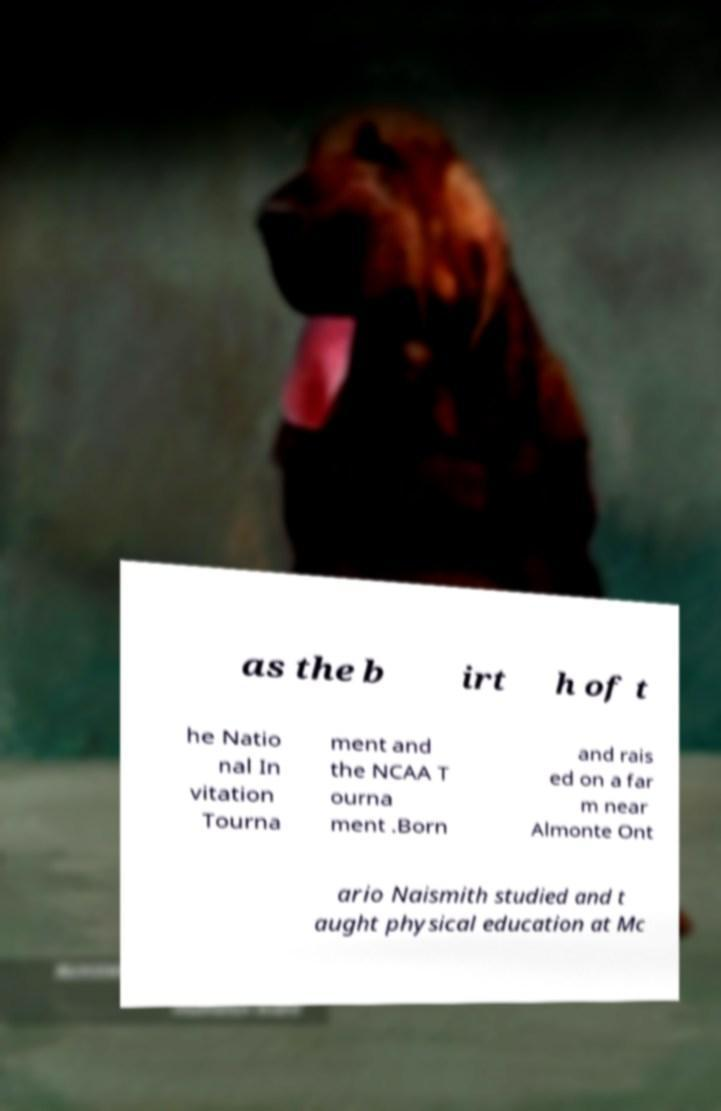I need the written content from this picture converted into text. Can you do that? as the b irt h of t he Natio nal In vitation Tourna ment and the NCAA T ourna ment .Born and rais ed on a far m near Almonte Ont ario Naismith studied and t aught physical education at Mc 